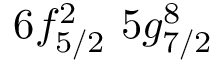<formula> <loc_0><loc_0><loc_500><loc_500>6 f _ { 5 / 2 } ^ { 2 } \, 5 g _ { 7 / 2 } ^ { 8 }</formula> 